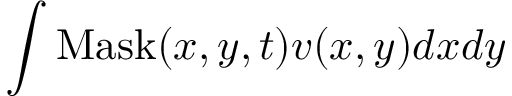Convert formula to latex. <formula><loc_0><loc_0><loc_500><loc_500>\int M a s k ( x , y , t ) v ( x , y ) d x d y</formula> 